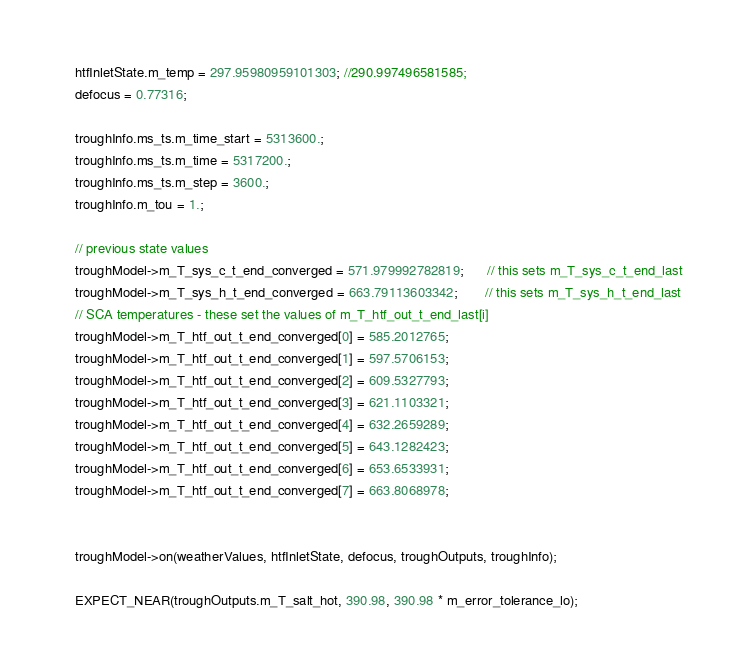Convert code to text. <code><loc_0><loc_0><loc_500><loc_500><_C++_>    htfInletState.m_temp = 297.95980959101303; //290.997496581585;
    defocus = 0.77316;

    troughInfo.ms_ts.m_time_start = 5313600.;
    troughInfo.ms_ts.m_time = 5317200.;
    troughInfo.ms_ts.m_step = 3600.;
    troughInfo.m_tou = 1.;

    // previous state values
    troughModel->m_T_sys_c_t_end_converged = 571.979992782819;      // this sets m_T_sys_c_t_end_last
    troughModel->m_T_sys_h_t_end_converged = 663.79113603342;       // this sets m_T_sys_h_t_end_last
    // SCA temperatures - these set the values of m_T_htf_out_t_end_last[i]
    troughModel->m_T_htf_out_t_end_converged[0] = 585.2012765;
    troughModel->m_T_htf_out_t_end_converged[1] = 597.5706153;
    troughModel->m_T_htf_out_t_end_converged[2] = 609.5327793;
    troughModel->m_T_htf_out_t_end_converged[3] = 621.1103321;
    troughModel->m_T_htf_out_t_end_converged[4] = 632.2659289;
    troughModel->m_T_htf_out_t_end_converged[5] = 643.1282423;
    troughModel->m_T_htf_out_t_end_converged[6] = 653.6533931;
    troughModel->m_T_htf_out_t_end_converged[7] = 663.8068978;


    troughModel->on(weatherValues, htfInletState, defocus, troughOutputs, troughInfo);

    EXPECT_NEAR(troughOutputs.m_T_salt_hot, 390.98, 390.98 * m_error_tolerance_lo);</code> 